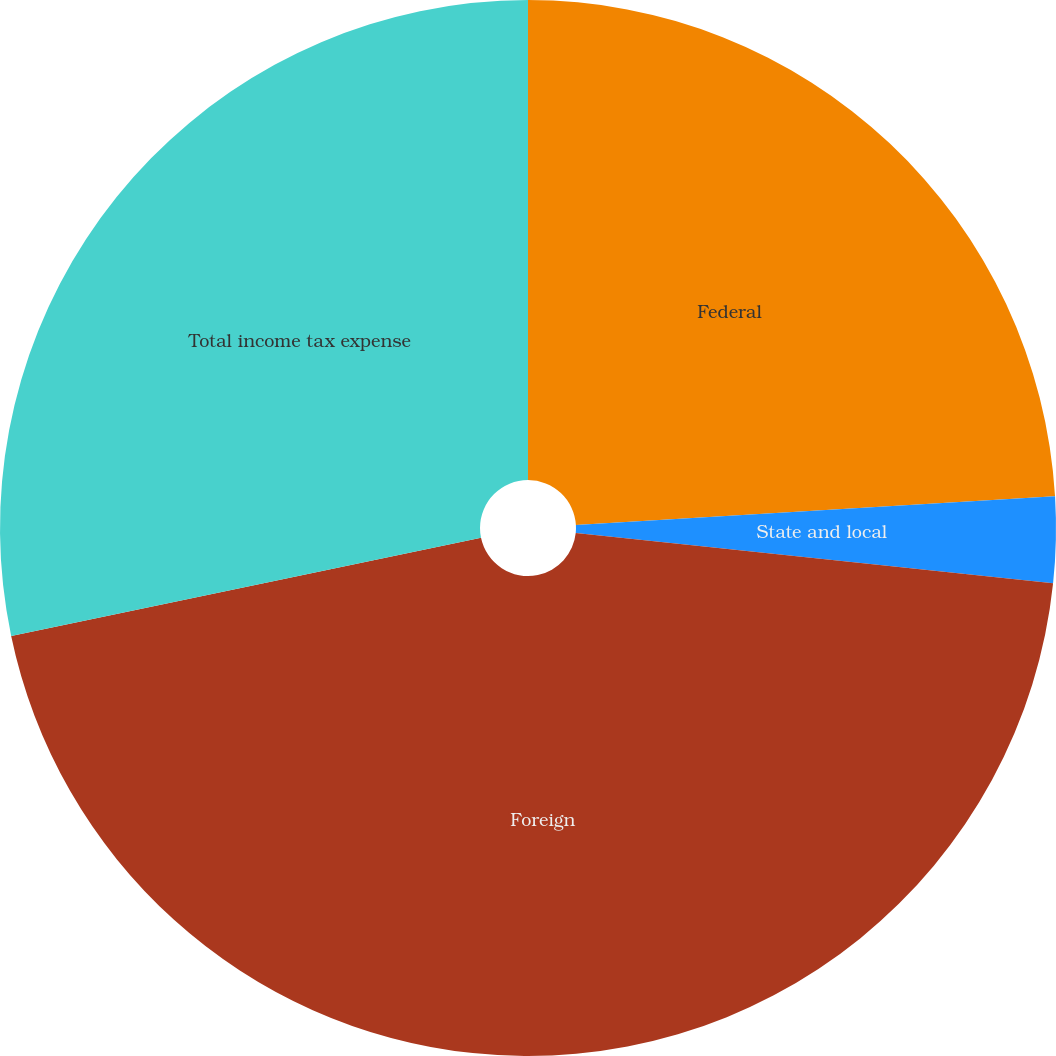<chart> <loc_0><loc_0><loc_500><loc_500><pie_chart><fcel>Federal<fcel>State and local<fcel>Foreign<fcel>Total income tax expense<nl><fcel>24.04%<fcel>2.63%<fcel>45.05%<fcel>28.28%<nl></chart> 